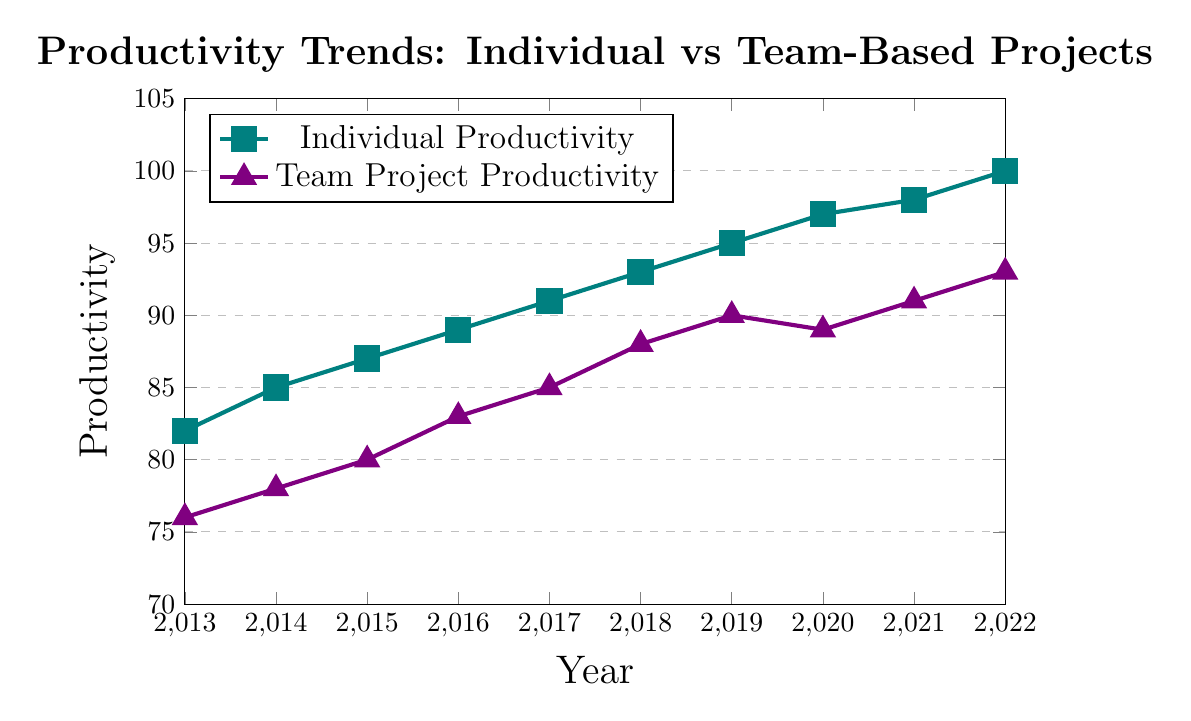What is the productivity trend for individual employees from 2013 to 2022? From 2013 to 2022, the productivity of individual employees consistently increases each year. Starting at 82 in 2013 and climbing steadily to 100 in 2022.
Answer: Consistently increasing trend How does the productivity of team projects in 2015 compare to that in 2020? In 2015, team project productivity is 80, while it grows to 89 by 2020. To compare: 89 (2020) - 80 (2015) = 9. The productivity of team projects in 2020 is 9 points higher than in 2015.
Answer: 9 points higher Which year shows the highest productivity for individual employees, and what is the value? The year 2022 shows the highest productivity for individual employees, with a value of 100.
Answer: 2022; 100 What is the average productivity for team projects from 2013 to 2017? To calculate the average productivity for team projects from 2013 to 2017: Sum the productivity values (76 + 78 + 80 + 83 + 85) = 402. Divide by the number of years (402 / 5) = 80.4.
Answer: 80.4 Compare the productivity changes between individual and team projects from 2018 to 2019. Which shows greater change and by how much? From 2018 to 2019, individual productivity increased from 93 to 95, a change of 2. Team project productivity increased from 88 to 90, a change of 2. Both show the same change of 2.
Answer: Same change; 2 points What is the difference in productivity between individual and team projects in 2014? In 2014, individual productivity is 85 and team project productivity is 78. The difference is calculated as: 85 - 78 = 7.
Answer: 7 Can you identify any year(s) where team project productivity decreased compared to the previous year? Team project productivity decreased from 2019 to 2020. In 2019, it was 90; in 2020, it was 89.
Answer: 2020 What is the median productivity value for individual employees over the decade? The individual productivity values are: 82, 85, 87, 89, 91, 93, 95, 97, 98, 100. To find the median, the middle values are 91 and 93. The median is (91 + 93) / 2 = 92.
Answer: 92 Which year has the smallest gap in productivity between individual employees and team projects? To find the smallest gap:
2013: 82 - 76 = 6
2014: 85 - 78 = 7
2015: 87 - 80 = 7
2016: 89 - 83 = 6
2017: 91 - 85 = 6
2018: 93 - 88 = 5
2019: 95 - 90 = 5
2020: 97 - 89 = 8
2021: 98 - 91 = 7
2022: 100 - 93 = 7
The smallest gap is in 2018 and 2019 with a gap of 5.
Answer: 2018 and 2019; 5 What is the total increase in productivity for individual employees from 2013 to 2022? To find the total increase, subtract the 2013 value from the 2022 value: 100 (2022) - 82 (2013) = 18.
Answer: 18 